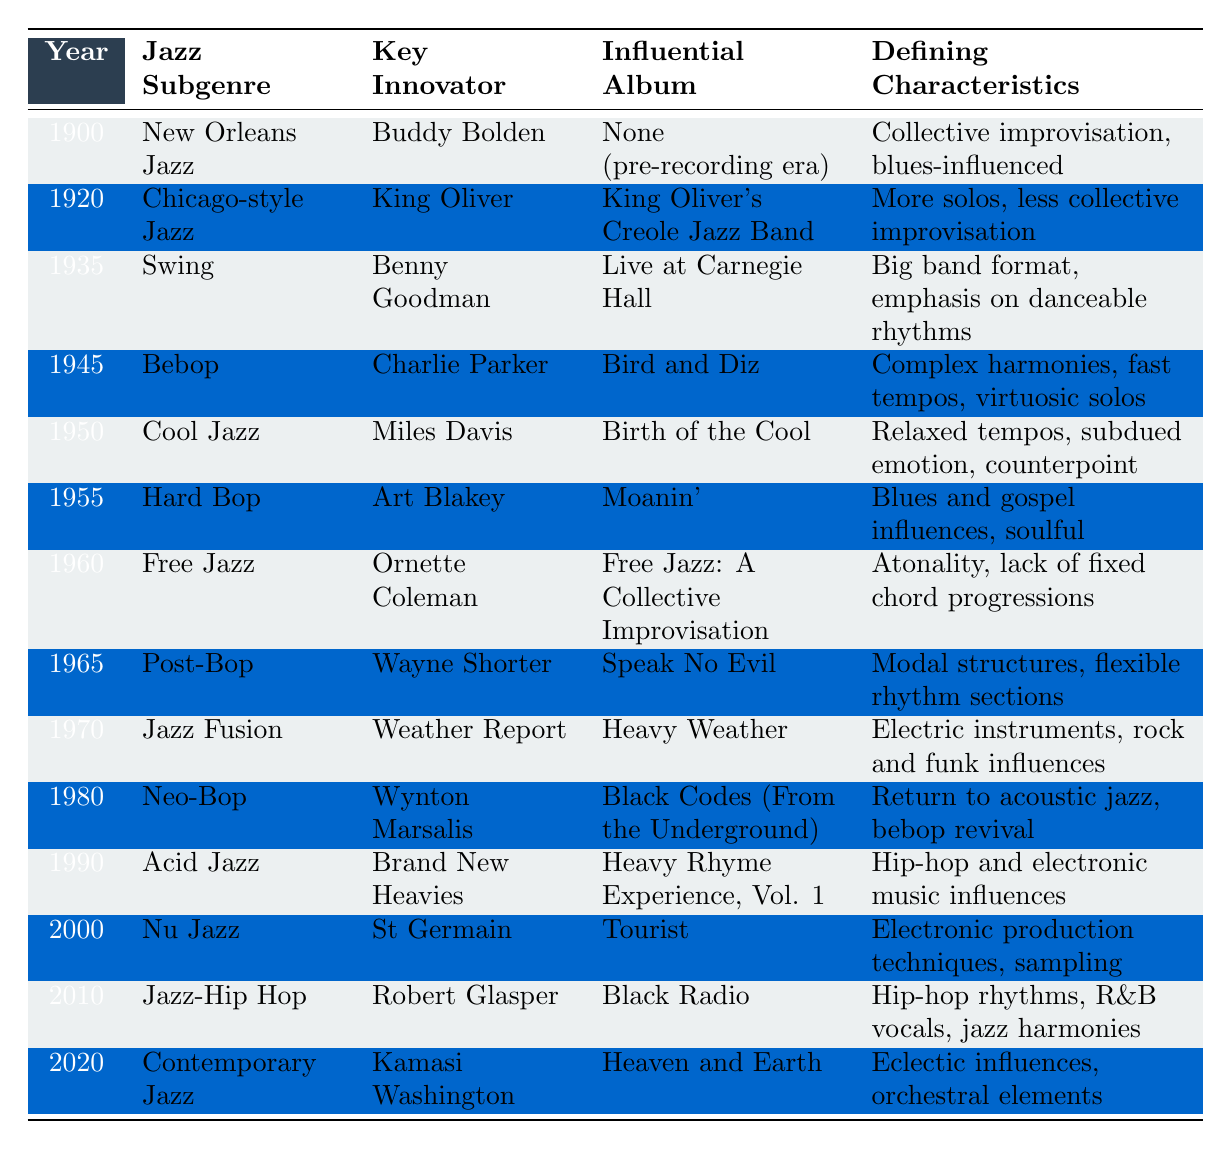What year did Bebop emerge? According to the table, Bebop is listed under the year 1945.
Answer: 1945 Who was the key innovator for Cool Jazz? The table indicates that Miles Davis is the key innovator for Cool Jazz.
Answer: Miles Davis Which jazz subgenre was characterized by electric instruments and rock influences? The table shows that Jazz Fusion, emerging in 1970, was characterized by electric instruments and rock influences.
Answer: Jazz Fusion What influential album is associated with New Orleans Jazz? New Orleans Jazz does not have an influential album associated with it as indicated by "None (pre-recording era)" in the table.
Answer: None Which jazz subgenre came immediately after Swing? The table lists Bebop as the subgenre that came immediately after Swing, which was established in 1935.
Answer: Bebop Was Hard Bop more influenced by blues and gospel compared to Bebop? Yes, based on the table, Hard Bop is noted for its blues and gospel influences, while Bebop focuses on complex harmonies.
Answer: Yes How many years apart were the introductions of Free Jazz and Acid Jazz? Free Jazz was introduced in 1960, and Acid Jazz appeared in 1990. The difference in years is 1990 - 1960 = 30 years.
Answer: 30 years What defining characteristic differentiates Jazz-Hip Hop from traditional Jazz? The defining characteristic for Jazz-Hip Hop includes hip-hop rhythms and R&B vocals, which distinguishes it from traditional forms of Jazz.
Answer: Hip-hop rhythms and R&B vocals Which jazz subgenre had the influential album "Birth of the Cool"? The table shows that Cool Jazz, identified with Miles Davis, had the album "Birth of the Cool."
Answer: Cool Jazz Is the defining characteristic of Contemporary Jazz eclectic influences? Yes, the table confirms that the defining characteristic of Contemporary Jazz is indeed eclectic influences and orchestral elements.
Answer: Yes Which subgenre is recognized for its modal structures? Post-Bop, as indicated in the table next to Wayne Shorter, is recognized for its modal structures.
Answer: Post-Bop Are there more jazz subgenres from the 1970s than the 1960s in the table? Yes, the table lists three subgenres from the 1970s (Jazz Fusion) and two from the 1960s (Free Jazz, Post-Bop). Hence, there is one more subgenre from the 1970s.
Answer: Yes How many key innovators were listed in the table? The table mentions 14 different key innovators corresponding to each subgenre listed.
Answer: 14 What is unique about the album associated with Nu Jazz compared to earlier genres? "Tourist," the album associated with Nu Jazz, employs electronic production techniques and sampling, differentiating it from earlier genres which mainly focused on acoustic sounds.
Answer: Electronic production techniques and sampling 